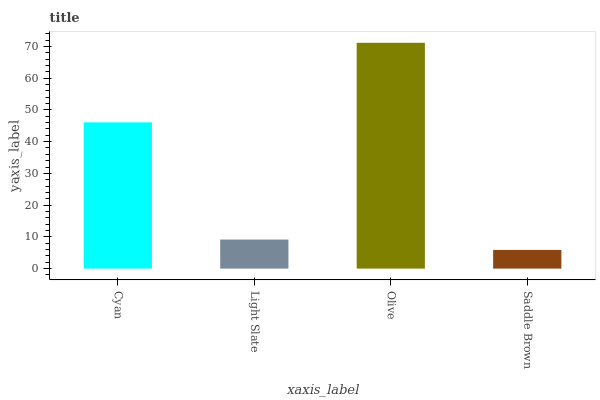Is Saddle Brown the minimum?
Answer yes or no. Yes. Is Olive the maximum?
Answer yes or no. Yes. Is Light Slate the minimum?
Answer yes or no. No. Is Light Slate the maximum?
Answer yes or no. No. Is Cyan greater than Light Slate?
Answer yes or no. Yes. Is Light Slate less than Cyan?
Answer yes or no. Yes. Is Light Slate greater than Cyan?
Answer yes or no. No. Is Cyan less than Light Slate?
Answer yes or no. No. Is Cyan the high median?
Answer yes or no. Yes. Is Light Slate the low median?
Answer yes or no. Yes. Is Saddle Brown the high median?
Answer yes or no. No. Is Saddle Brown the low median?
Answer yes or no. No. 